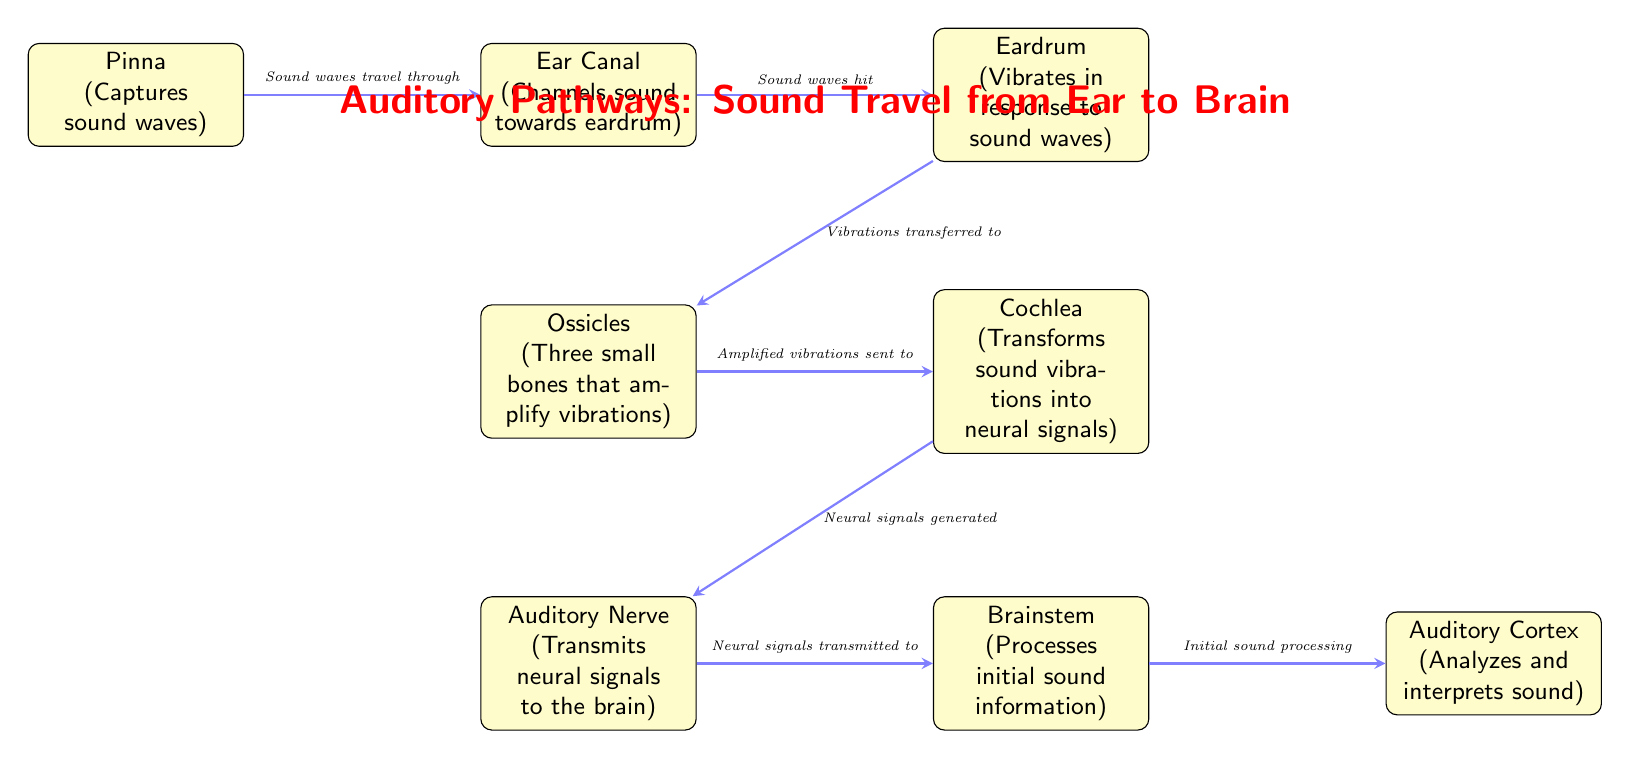What captures sound waves? The diagram indicates that the Pinna captures sound waves. It is the first element in the auditory pathway and is specifically noted for this function.
Answer: Pinna What is the function of the cochlea? The diagram states that the cochlea transforms sound vibrations into neural signals, making it essential for converting mechanical vibrations into a form that the brain can process.
Answer: Transforms sound vibrations into neural signals How many bones are in the ossicles? The diagram mentions "Three small bones that amplify vibrations" in the ossicles, indicating their role in the auditory pathway.
Answer: Three What transmits neural signals to the brain? According to the diagram, the Auditory Nerve is responsible for transmitting neural signals from the cochlea to the brain. This connection is critical for auditory processing.
Answer: Auditory Nerve What is the role of the auditory cortex? The diagram shows that the Auditory Cortex analyzes and interprets sound, indicating that it is involved in higher-level processing after the initial sound signal is transmitted.
Answer: Analyzes and interprets sound What follows after the eardrum? The diagram illustrates that after the eardrum vibrates in response to sound waves, the vibrations are transferred to the ossicles. This indicates the sequence of signal processing along the auditory pathway.
Answer: Ossicles What processes initial sound information? According to the diagram, the Brainstem processes initial sound information, making it vital for the early stages of auditory perception.
Answer: Brainstem Which structure is directly connected to the cochlea? The diagram shows that the Auditory Nerve is directly connected to the cochlea, indicating the pathway of neural signal transmission following sound transformation.
Answer: Auditory Nerve 